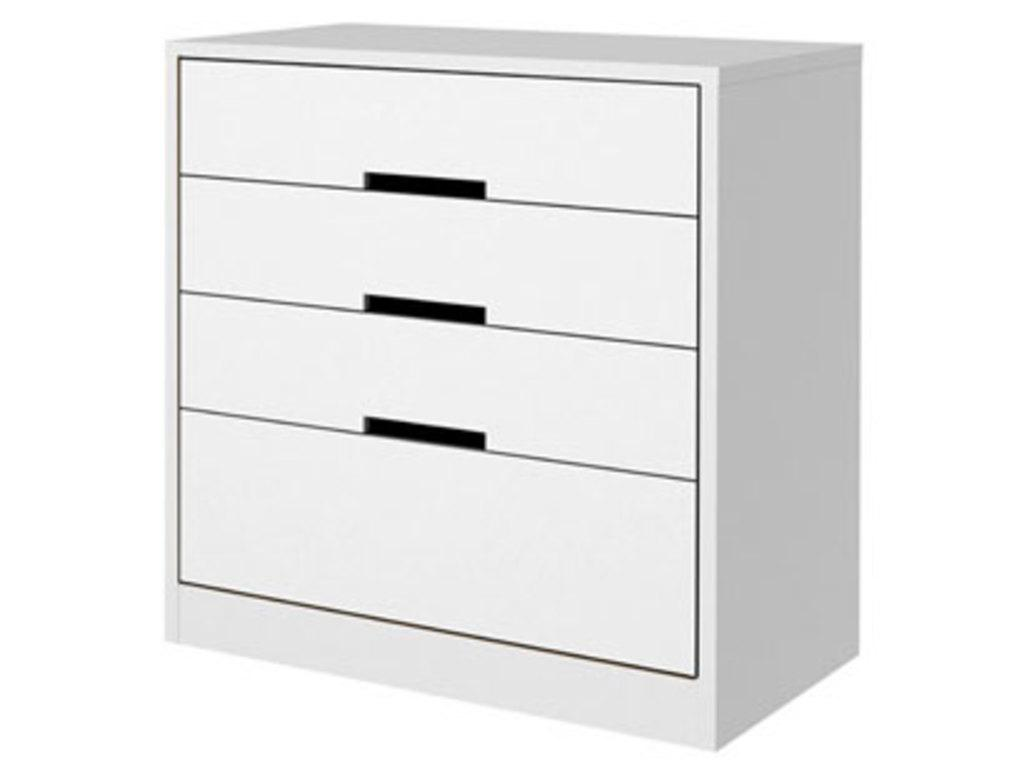What piece of furniture is present in the image? There is a desk in the image. What color is the background of the image? The background of the image is white. How many dinosaurs can be seen in the image? There are no dinosaurs present in the image. What type of clothing are the giants wearing in the image? There are no giants present in the image. 